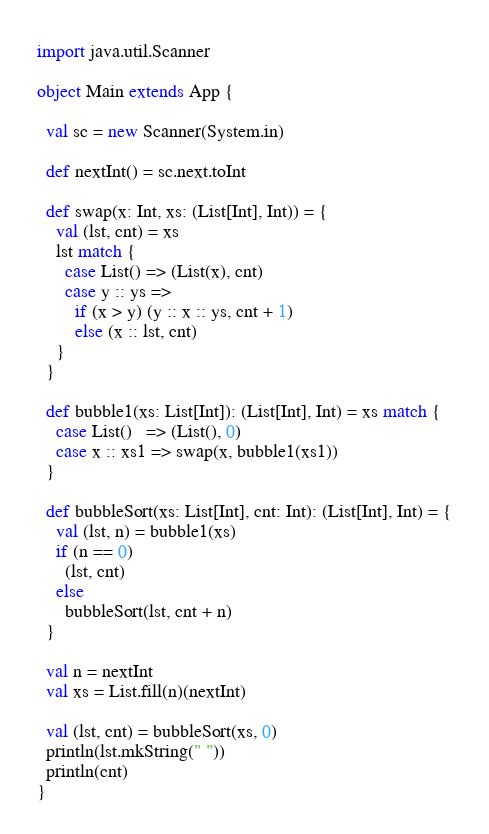<code> <loc_0><loc_0><loc_500><loc_500><_Scala_>import java.util.Scanner

object Main extends App {

  val sc = new Scanner(System.in)

  def nextInt() = sc.next.toInt

  def swap(x: Int, xs: (List[Int], Int)) = {
    val (lst, cnt) = xs
    lst match {
      case List() => (List(x), cnt)
      case y :: ys =>
        if (x > y) (y :: x :: ys, cnt + 1)
        else (x :: lst, cnt)
    }
  }

  def bubble1(xs: List[Int]): (List[Int], Int) = xs match {
    case List()   => (List(), 0)
    case x :: xs1 => swap(x, bubble1(xs1))
  }

  def bubbleSort(xs: List[Int], cnt: Int): (List[Int], Int) = {
    val (lst, n) = bubble1(xs)
    if (n == 0)
      (lst, cnt)
    else
      bubbleSort(lst, cnt + n)
  }

  val n = nextInt
  val xs = List.fill(n)(nextInt)

  val (lst, cnt) = bubbleSort(xs, 0)
  println(lst.mkString(" "))
  println(cnt)
}

</code> 